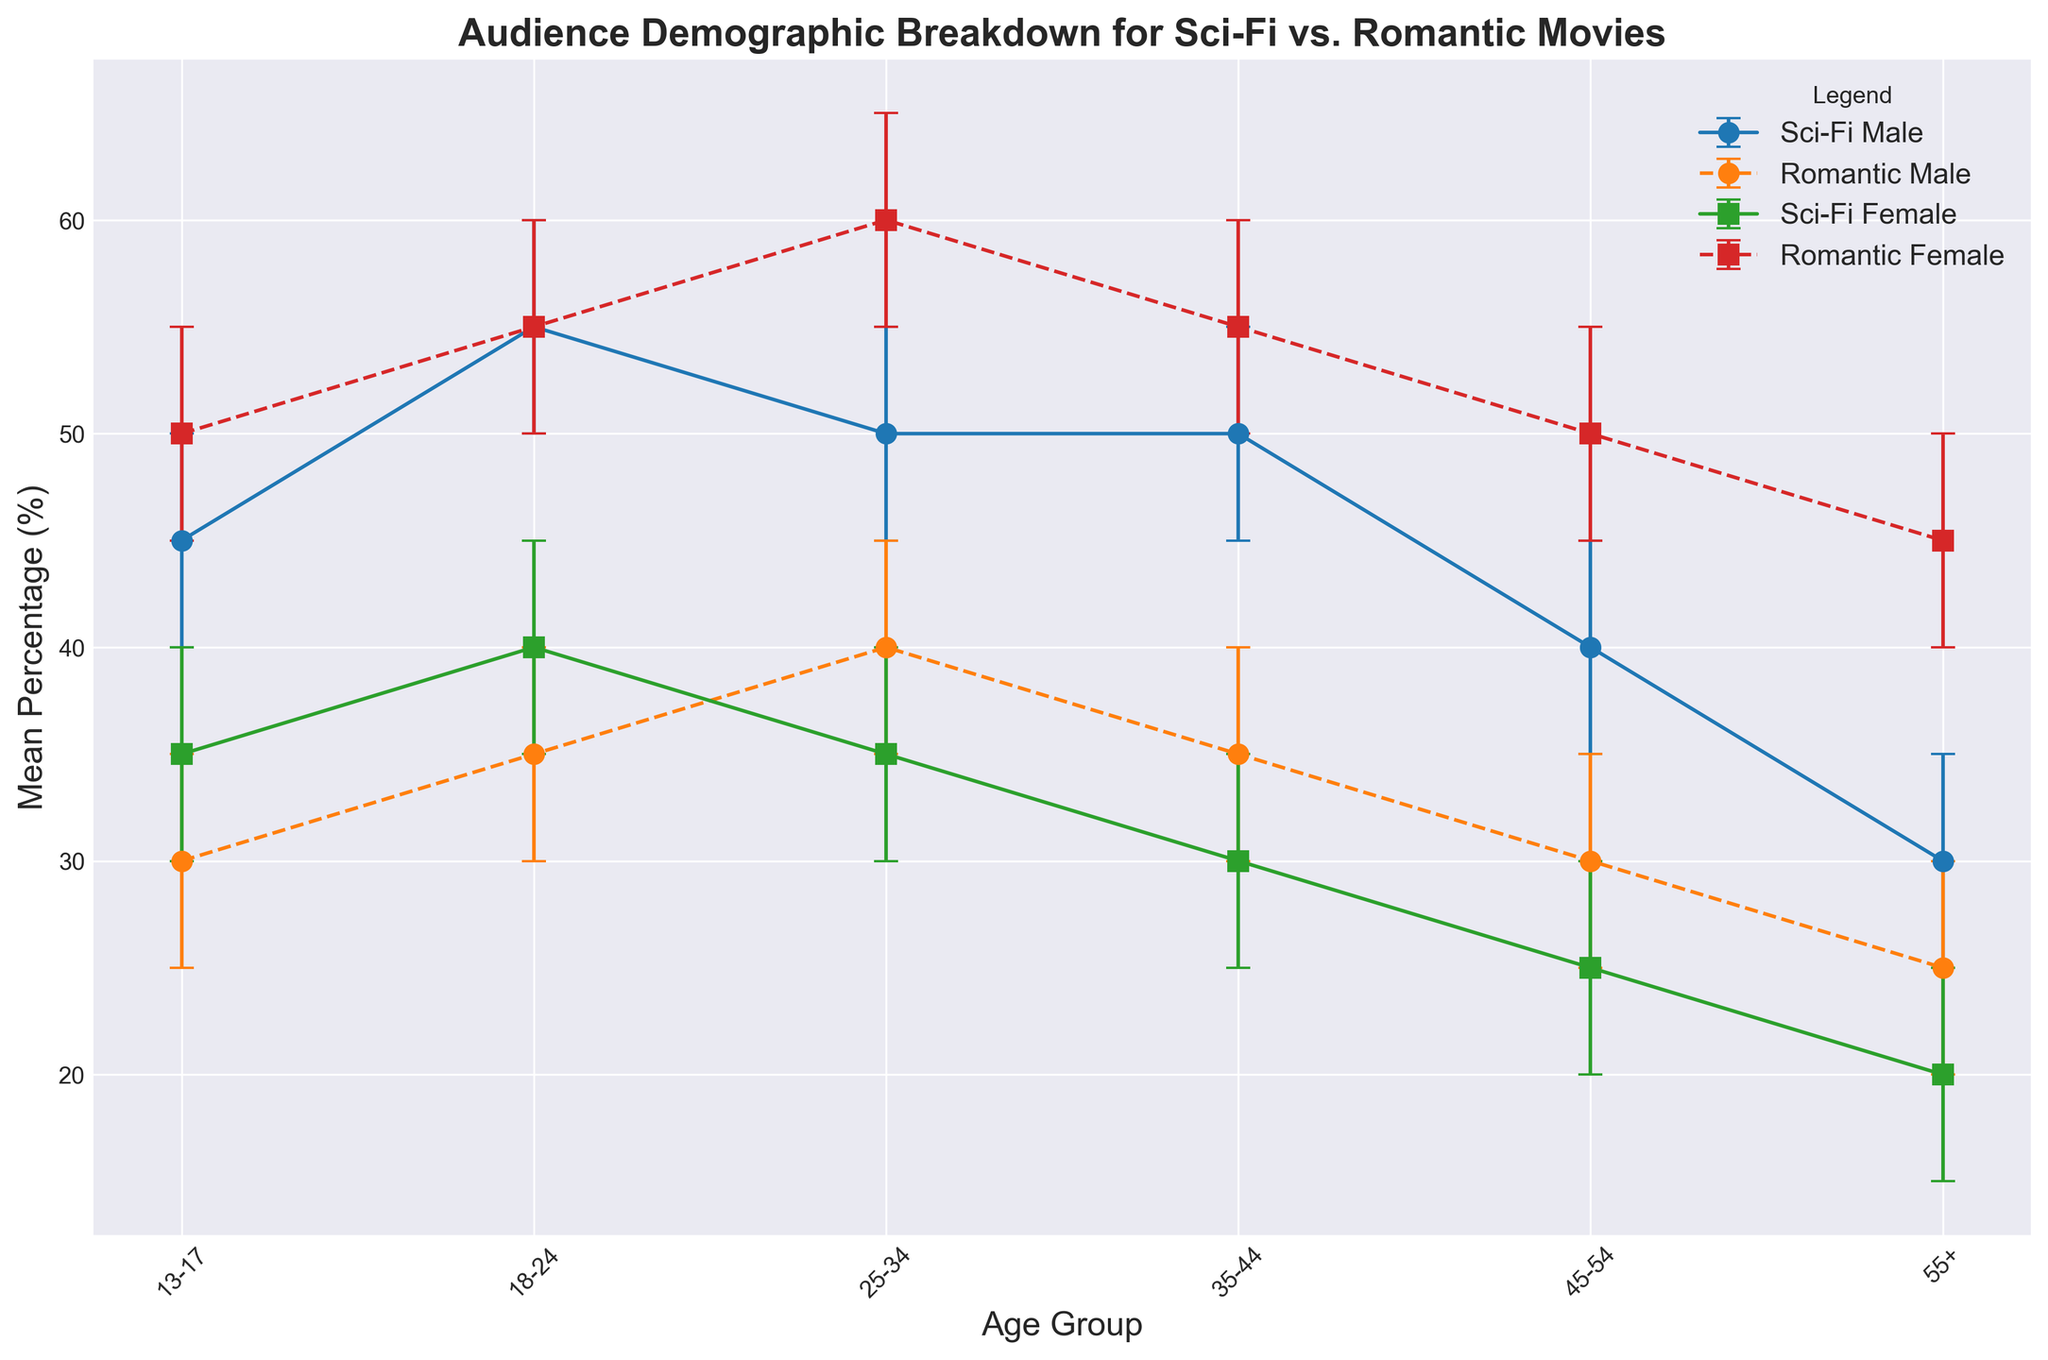Which age group has the highest mean percentage of female viewers for romantic movies? Look at the data for female viewers of romantic movies and identify the age group with the highest percentage. The age group 25-34 has the highest percentage with a mean of 60%.
Answer: 25-34 Which genre has more male viewers aged 13-17? Compare the mean percentages of male viewers aged 13-17 for both genres. Sci-fi has 45% male viewers while romantic has 30%. Thus, sci-fi has more male viewers in this age group.
Answer: Sci-fi What is the difference in mean percentage between male and female viewers aged 18-24 for sci-fi movies? Find the mean percentages for male and female viewers aged 18-24 in the sci-fi genre. For males, it is 55%, and for females, it is 40%. The difference is 55% - 40% = 15%.
Answer: 15% Which gender has more variance in viewership percentages for romantic movies across all age groups? Look at the error bars for each age group and gender in the romantic genre. Female viewers have wider error bars, indicating greater variance in percentages.
Answer: Female What is the combined mean percentage for male viewers aged 35-44 in both genres? Add the mean percentages for male viewers aged 35-44 in the sci-fi and romantic genres. For sci-fi, it is 50%, and for romantic, it is 35%. Combined, this is 50% + 35% = 85%.
Answer: 85% For sci-fi movies, which age group of female viewers has the lowest upper confidence interval? Identify the upper confidence intervals for female viewers in the sci-fi genre across all age groups. The age group 55+ has the lowest upper confidence interval of 25%.
Answer: 55+ Are male viewers aged 45-54 more likely to watch sci-fi or romantic movies? Compare the mean percentages for male viewers aged 45-54 in both genres. For sci-fi, it is 40%, and for romantic, it is 30%. Therefore, they are more likely to watch sci-fi.
Answer: Sci-fi What is the range of the confidence interval for female viewers aged 25-34 watching romantic movies? Look at the lower and upper bounds of the confidence interval for this group. The lower bound is 55%, and the upper bound is 65%. The range is 65% - 55% = 10%.
Answer: 10% For which genre and age group is the confidence interval widest for female viewers? Compare the width of the confidence intervals for female viewers across all age groups and genres. The age group 13-17 watching romantic movies has the widest interval, 55% - 45% = 10%.
Answer: Romantic, 13-17 Which age group of male viewers shows the least interest in sci-fi movies based on mean percentage? Identify the age group of male viewers with the lowest mean percentage in the sci-fi genre. The age group 55+ shows the least interest with a mean of 30%.
Answer: 55+ 